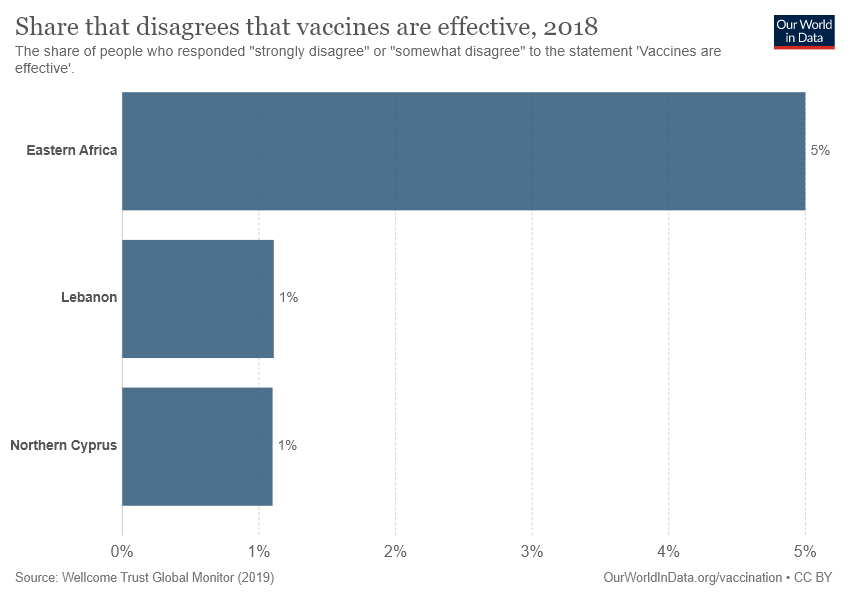Point out several critical features in this image. The average of all the data is 2.33... Lebanon data refers to a range of values from 0.01 to... 